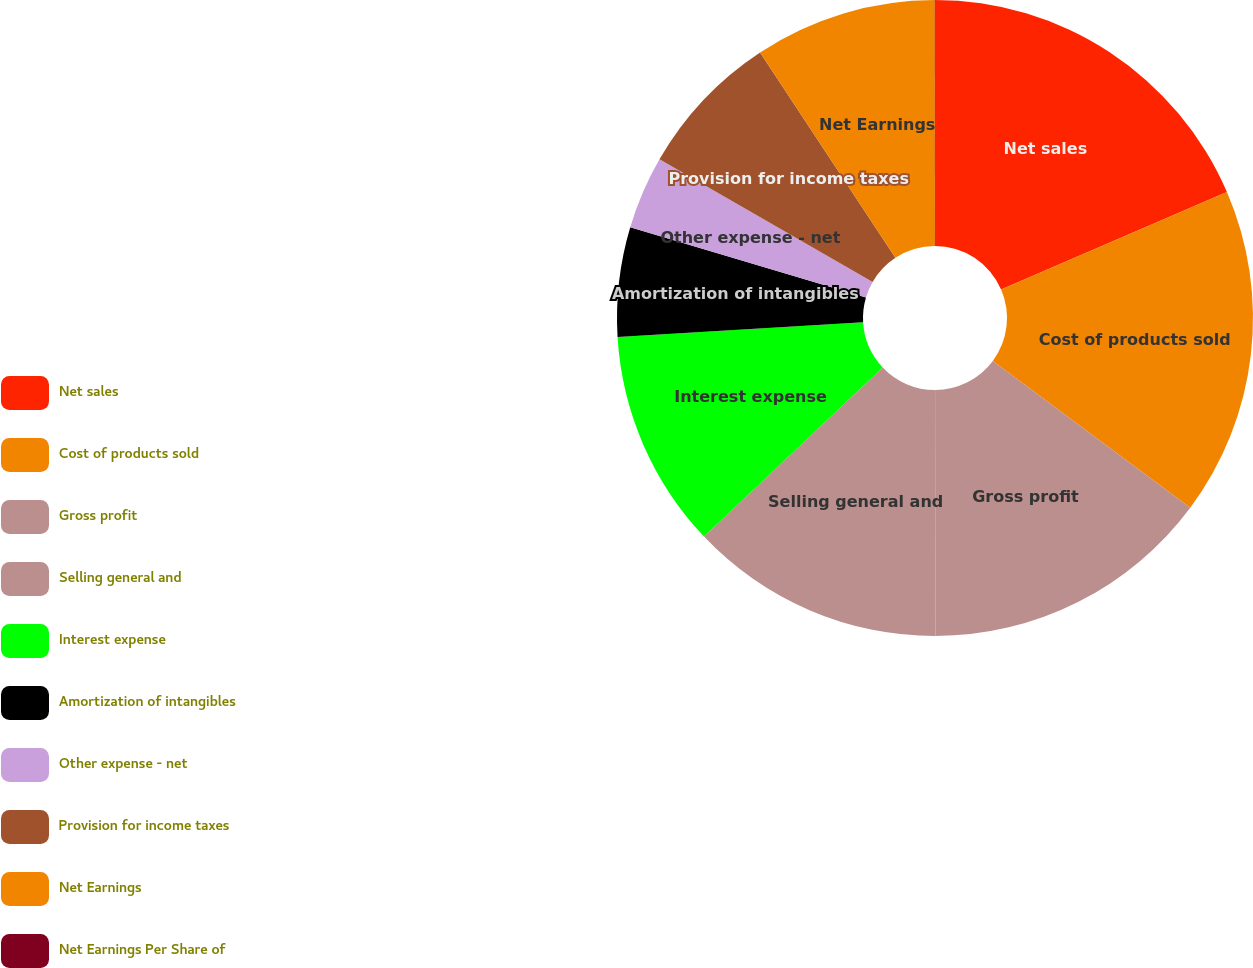<chart> <loc_0><loc_0><loc_500><loc_500><pie_chart><fcel>Net sales<fcel>Cost of products sold<fcel>Gross profit<fcel>Selling general and<fcel>Interest expense<fcel>Amortization of intangibles<fcel>Other expense - net<fcel>Provision for income taxes<fcel>Net Earnings<fcel>Net Earnings Per Share of<nl><fcel>18.51%<fcel>16.66%<fcel>14.81%<fcel>12.96%<fcel>11.11%<fcel>5.56%<fcel>3.71%<fcel>7.41%<fcel>9.26%<fcel>0.01%<nl></chart> 